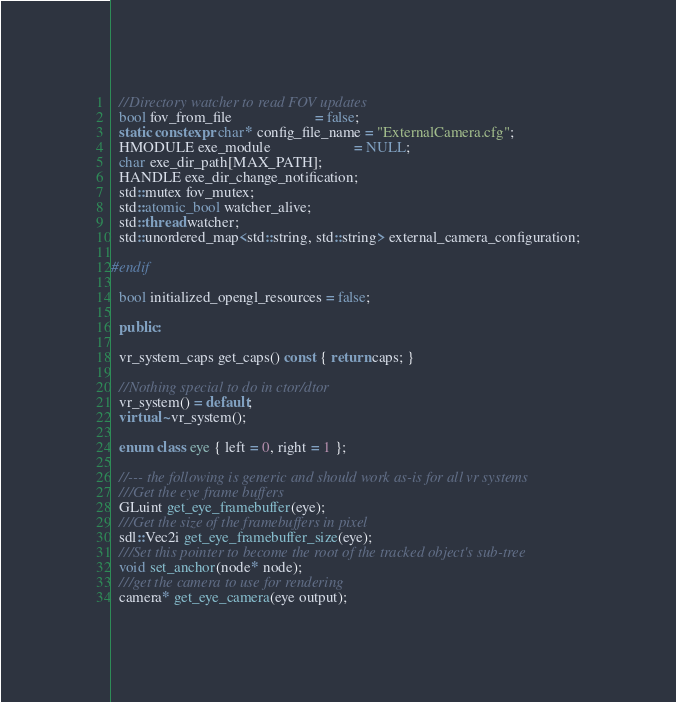<code> <loc_0><loc_0><loc_500><loc_500><_C++_>
  //Directory watcher to read FOV updates
  bool fov_from_file                      = false;
  static constexpr char* config_file_name = "ExternalCamera.cfg";
  HMODULE exe_module                      = NULL;
  char exe_dir_path[MAX_PATH];
  HANDLE exe_dir_change_notification;
  std::mutex fov_mutex;
  std::atomic_bool watcher_alive;
  std::thread watcher;
  std::unordered_map<std::string, std::string> external_camera_configuration;

#endif

  bool initialized_opengl_resources = false;

  public:

  vr_system_caps get_caps() const { return caps; }

  //Nothing special to do in ctor/dtor
  vr_system() = default;
  virtual ~vr_system();

  enum class eye { left = 0, right = 1 };

  //--- the following is generic and should work as-is for all vr systems
  ///Get the eye frame buffers
  GLuint get_eye_framebuffer(eye);
  ///Get the size of the framebuffers in pixel
  sdl::Vec2i get_eye_framebuffer_size(eye);
  ///Set this pointer to become the root of the tracked object's sub-tree
  void set_anchor(node* node);
  ///get the camera to use for rendering
  camera* get_eye_camera(eye output);
</code> 